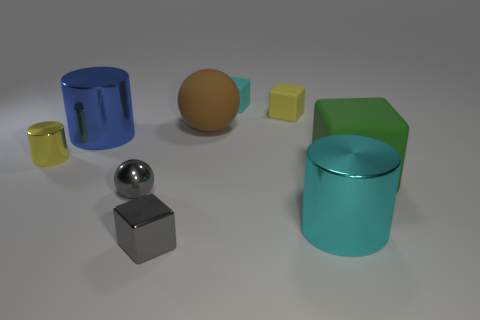How many tiny metal things have the same color as the small metallic cube?
Provide a short and direct response. 1. There is another rubber block that is the same size as the yellow rubber block; what is its color?
Give a very brief answer. Cyan. What is the size of the shiny object that is the same color as the small metal block?
Offer a terse response. Small. Is there any other thing that has the same material as the tiny gray block?
Give a very brief answer. Yes. There is a yellow thing that is behind the small metal object that is on the left side of the big blue shiny object; are there any shiny cylinders on the left side of it?
Provide a short and direct response. Yes. There is a small cube in front of the tiny metal cylinder; what is it made of?
Your response must be concise. Metal. What number of tiny things are either metallic blocks or yellow rubber cubes?
Give a very brief answer. 2. Do the gray thing that is in front of the gray ball and the yellow metallic cylinder have the same size?
Make the answer very short. Yes. What number of other things are the same color as the tiny shiny sphere?
Give a very brief answer. 1. What is the material of the brown thing?
Your answer should be very brief. Rubber. 